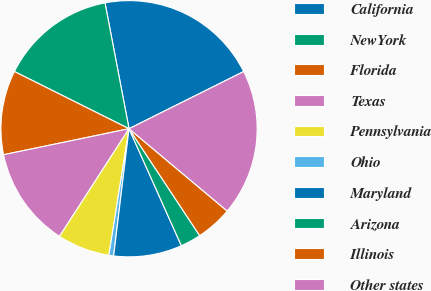<chart> <loc_0><loc_0><loc_500><loc_500><pie_chart><fcel>California<fcel>NewYork<fcel>Florida<fcel>Texas<fcel>Pennsylvania<fcel>Ohio<fcel>Maryland<fcel>Arizona<fcel>Illinois<fcel>Other states<nl><fcel>20.64%<fcel>14.63%<fcel>10.62%<fcel>12.62%<fcel>6.61%<fcel>0.6%<fcel>8.61%<fcel>2.6%<fcel>4.6%<fcel>18.47%<nl></chart> 